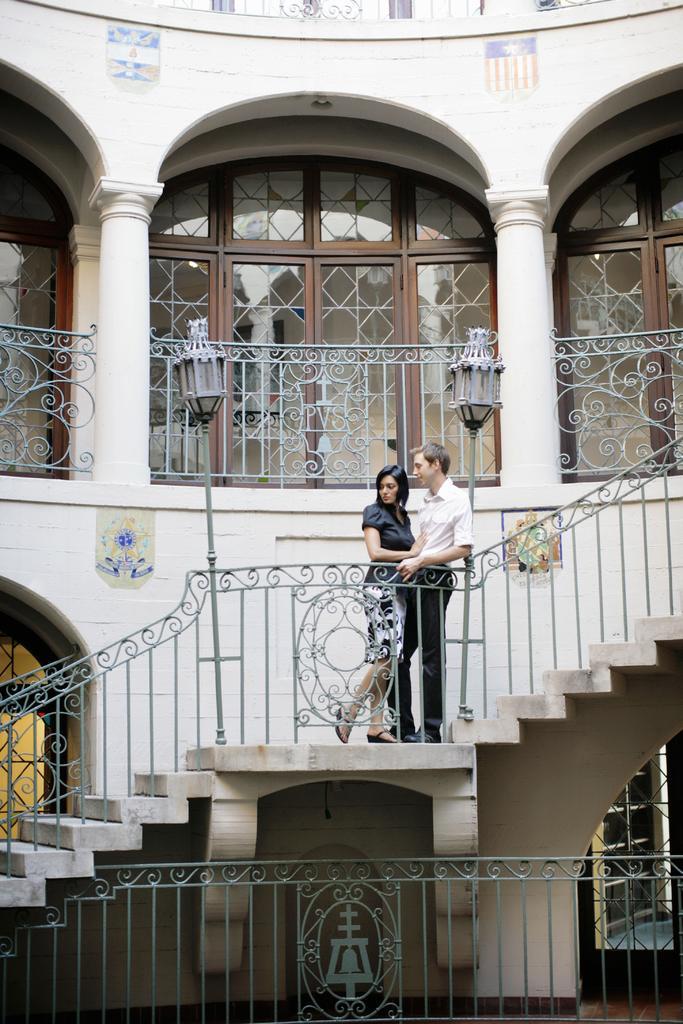Could you give a brief overview of what you see in this image? This image consists of two persons a man and a woman. The man is wearing a black pant and white shirt. The woman is wearing a black dress. In the front, we can see steps along with the railing. And there is a building along with windows and pillars. 